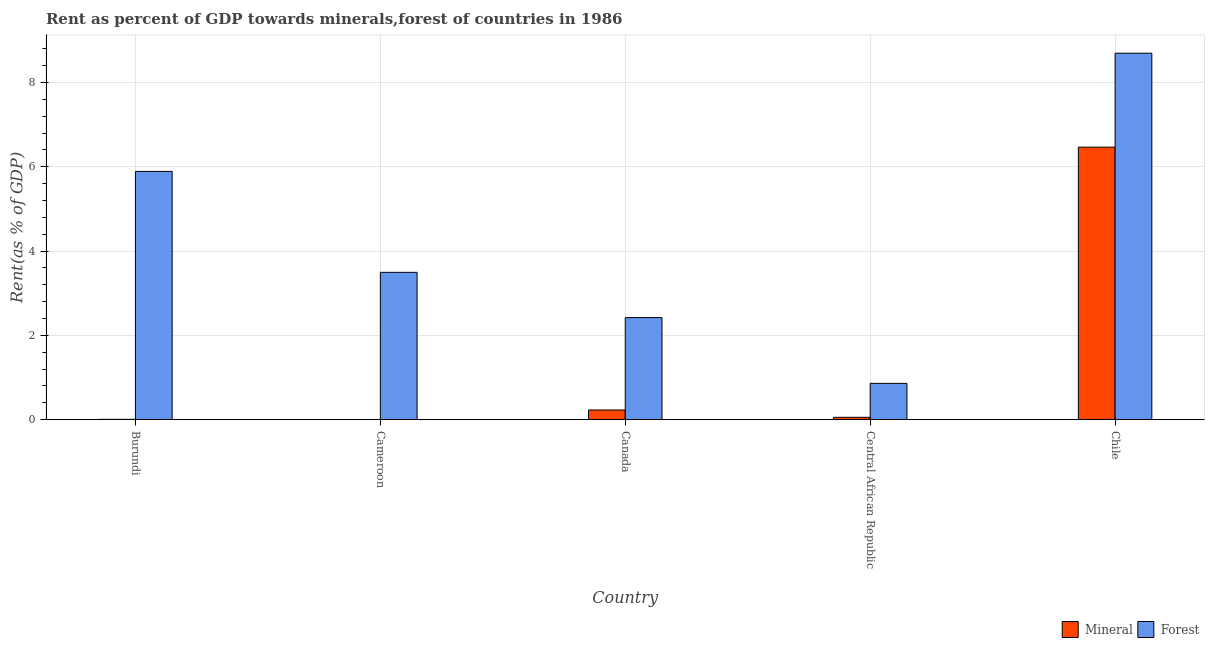What is the label of the 2nd group of bars from the left?
Offer a very short reply. Cameroon. What is the forest rent in Central African Republic?
Ensure brevity in your answer.  0.86. Across all countries, what is the maximum forest rent?
Keep it short and to the point. 8.7. Across all countries, what is the minimum forest rent?
Offer a very short reply. 0.86. In which country was the mineral rent maximum?
Provide a short and direct response. Chile. In which country was the mineral rent minimum?
Make the answer very short. Cameroon. What is the total forest rent in the graph?
Offer a terse response. 21.37. What is the difference between the forest rent in Burundi and that in Canada?
Keep it short and to the point. 3.47. What is the difference between the mineral rent in Chile and the forest rent in Central African Republic?
Your response must be concise. 5.6. What is the average mineral rent per country?
Provide a succinct answer. 1.35. What is the difference between the forest rent and mineral rent in Central African Republic?
Ensure brevity in your answer.  0.81. What is the ratio of the mineral rent in Burundi to that in Chile?
Your answer should be very brief. 0. What is the difference between the highest and the second highest forest rent?
Ensure brevity in your answer.  2.8. What is the difference between the highest and the lowest forest rent?
Provide a succinct answer. 7.83. In how many countries, is the forest rent greater than the average forest rent taken over all countries?
Keep it short and to the point. 2. Is the sum of the forest rent in Canada and Chile greater than the maximum mineral rent across all countries?
Give a very brief answer. Yes. What does the 2nd bar from the left in Canada represents?
Keep it short and to the point. Forest. What does the 1st bar from the right in Central African Republic represents?
Provide a short and direct response. Forest. Are all the bars in the graph horizontal?
Provide a short and direct response. No. How many countries are there in the graph?
Your response must be concise. 5. Are the values on the major ticks of Y-axis written in scientific E-notation?
Offer a terse response. No. Does the graph contain any zero values?
Make the answer very short. No. Does the graph contain grids?
Offer a terse response. Yes. How many legend labels are there?
Keep it short and to the point. 2. How are the legend labels stacked?
Your answer should be compact. Horizontal. What is the title of the graph?
Your response must be concise. Rent as percent of GDP towards minerals,forest of countries in 1986. What is the label or title of the X-axis?
Keep it short and to the point. Country. What is the label or title of the Y-axis?
Offer a terse response. Rent(as % of GDP). What is the Rent(as % of GDP) in Mineral in Burundi?
Make the answer very short. 0.01. What is the Rent(as % of GDP) in Forest in Burundi?
Keep it short and to the point. 5.89. What is the Rent(as % of GDP) of Mineral in Cameroon?
Your answer should be very brief. 0. What is the Rent(as % of GDP) of Forest in Cameroon?
Ensure brevity in your answer.  3.5. What is the Rent(as % of GDP) in Mineral in Canada?
Your answer should be compact. 0.23. What is the Rent(as % of GDP) in Forest in Canada?
Ensure brevity in your answer.  2.42. What is the Rent(as % of GDP) of Mineral in Central African Republic?
Offer a very short reply. 0.06. What is the Rent(as % of GDP) in Forest in Central African Republic?
Provide a succinct answer. 0.86. What is the Rent(as % of GDP) of Mineral in Chile?
Your response must be concise. 6.47. What is the Rent(as % of GDP) in Forest in Chile?
Your answer should be compact. 8.7. Across all countries, what is the maximum Rent(as % of GDP) of Mineral?
Provide a succinct answer. 6.47. Across all countries, what is the maximum Rent(as % of GDP) of Forest?
Ensure brevity in your answer.  8.7. Across all countries, what is the minimum Rent(as % of GDP) in Mineral?
Keep it short and to the point. 0. Across all countries, what is the minimum Rent(as % of GDP) of Forest?
Offer a terse response. 0.86. What is the total Rent(as % of GDP) in Mineral in the graph?
Offer a terse response. 6.76. What is the total Rent(as % of GDP) in Forest in the graph?
Provide a short and direct response. 21.37. What is the difference between the Rent(as % of GDP) in Mineral in Burundi and that in Cameroon?
Ensure brevity in your answer.  0.01. What is the difference between the Rent(as % of GDP) in Forest in Burundi and that in Cameroon?
Ensure brevity in your answer.  2.39. What is the difference between the Rent(as % of GDP) of Mineral in Burundi and that in Canada?
Give a very brief answer. -0.22. What is the difference between the Rent(as % of GDP) in Forest in Burundi and that in Canada?
Make the answer very short. 3.47. What is the difference between the Rent(as % of GDP) of Mineral in Burundi and that in Central African Republic?
Keep it short and to the point. -0.05. What is the difference between the Rent(as % of GDP) of Forest in Burundi and that in Central African Republic?
Offer a very short reply. 5.03. What is the difference between the Rent(as % of GDP) of Mineral in Burundi and that in Chile?
Give a very brief answer. -6.46. What is the difference between the Rent(as % of GDP) in Forest in Burundi and that in Chile?
Offer a terse response. -2.8. What is the difference between the Rent(as % of GDP) in Mineral in Cameroon and that in Canada?
Provide a short and direct response. -0.23. What is the difference between the Rent(as % of GDP) of Forest in Cameroon and that in Canada?
Your answer should be very brief. 1.07. What is the difference between the Rent(as % of GDP) in Mineral in Cameroon and that in Central African Republic?
Keep it short and to the point. -0.06. What is the difference between the Rent(as % of GDP) of Forest in Cameroon and that in Central African Republic?
Your answer should be very brief. 2.63. What is the difference between the Rent(as % of GDP) of Mineral in Cameroon and that in Chile?
Provide a succinct answer. -6.47. What is the difference between the Rent(as % of GDP) of Forest in Cameroon and that in Chile?
Offer a terse response. -5.2. What is the difference between the Rent(as % of GDP) in Mineral in Canada and that in Central African Republic?
Your answer should be very brief. 0.17. What is the difference between the Rent(as % of GDP) in Forest in Canada and that in Central African Republic?
Your response must be concise. 1.56. What is the difference between the Rent(as % of GDP) of Mineral in Canada and that in Chile?
Your response must be concise. -6.24. What is the difference between the Rent(as % of GDP) in Forest in Canada and that in Chile?
Provide a succinct answer. -6.27. What is the difference between the Rent(as % of GDP) in Mineral in Central African Republic and that in Chile?
Offer a very short reply. -6.41. What is the difference between the Rent(as % of GDP) of Forest in Central African Republic and that in Chile?
Give a very brief answer. -7.83. What is the difference between the Rent(as % of GDP) of Mineral in Burundi and the Rent(as % of GDP) of Forest in Cameroon?
Ensure brevity in your answer.  -3.49. What is the difference between the Rent(as % of GDP) of Mineral in Burundi and the Rent(as % of GDP) of Forest in Canada?
Keep it short and to the point. -2.41. What is the difference between the Rent(as % of GDP) in Mineral in Burundi and the Rent(as % of GDP) in Forest in Central African Republic?
Make the answer very short. -0.85. What is the difference between the Rent(as % of GDP) of Mineral in Burundi and the Rent(as % of GDP) of Forest in Chile?
Offer a very short reply. -8.69. What is the difference between the Rent(as % of GDP) of Mineral in Cameroon and the Rent(as % of GDP) of Forest in Canada?
Offer a terse response. -2.42. What is the difference between the Rent(as % of GDP) in Mineral in Cameroon and the Rent(as % of GDP) in Forest in Central African Republic?
Provide a short and direct response. -0.86. What is the difference between the Rent(as % of GDP) of Mineral in Cameroon and the Rent(as % of GDP) of Forest in Chile?
Provide a succinct answer. -8.69. What is the difference between the Rent(as % of GDP) of Mineral in Canada and the Rent(as % of GDP) of Forest in Central African Republic?
Offer a terse response. -0.63. What is the difference between the Rent(as % of GDP) in Mineral in Canada and the Rent(as % of GDP) in Forest in Chile?
Your answer should be very brief. -8.46. What is the difference between the Rent(as % of GDP) in Mineral in Central African Republic and the Rent(as % of GDP) in Forest in Chile?
Your answer should be very brief. -8.64. What is the average Rent(as % of GDP) of Mineral per country?
Ensure brevity in your answer.  1.35. What is the average Rent(as % of GDP) in Forest per country?
Provide a succinct answer. 4.27. What is the difference between the Rent(as % of GDP) of Mineral and Rent(as % of GDP) of Forest in Burundi?
Provide a short and direct response. -5.88. What is the difference between the Rent(as % of GDP) in Mineral and Rent(as % of GDP) in Forest in Cameroon?
Offer a terse response. -3.5. What is the difference between the Rent(as % of GDP) of Mineral and Rent(as % of GDP) of Forest in Canada?
Your answer should be compact. -2.19. What is the difference between the Rent(as % of GDP) of Mineral and Rent(as % of GDP) of Forest in Central African Republic?
Offer a very short reply. -0.81. What is the difference between the Rent(as % of GDP) in Mineral and Rent(as % of GDP) in Forest in Chile?
Offer a terse response. -2.23. What is the ratio of the Rent(as % of GDP) in Mineral in Burundi to that in Cameroon?
Ensure brevity in your answer.  33.14. What is the ratio of the Rent(as % of GDP) in Forest in Burundi to that in Cameroon?
Offer a terse response. 1.68. What is the ratio of the Rent(as % of GDP) in Mineral in Burundi to that in Canada?
Offer a very short reply. 0.04. What is the ratio of the Rent(as % of GDP) of Forest in Burundi to that in Canada?
Keep it short and to the point. 2.43. What is the ratio of the Rent(as % of GDP) of Mineral in Burundi to that in Central African Republic?
Provide a short and direct response. 0.15. What is the ratio of the Rent(as % of GDP) of Forest in Burundi to that in Central African Republic?
Offer a very short reply. 6.83. What is the ratio of the Rent(as % of GDP) of Mineral in Burundi to that in Chile?
Make the answer very short. 0. What is the ratio of the Rent(as % of GDP) in Forest in Burundi to that in Chile?
Give a very brief answer. 0.68. What is the ratio of the Rent(as % of GDP) of Mineral in Cameroon to that in Canada?
Your response must be concise. 0. What is the ratio of the Rent(as % of GDP) in Forest in Cameroon to that in Canada?
Your answer should be very brief. 1.44. What is the ratio of the Rent(as % of GDP) of Mineral in Cameroon to that in Central African Republic?
Keep it short and to the point. 0. What is the ratio of the Rent(as % of GDP) of Forest in Cameroon to that in Central African Republic?
Your response must be concise. 4.06. What is the ratio of the Rent(as % of GDP) of Forest in Cameroon to that in Chile?
Provide a short and direct response. 0.4. What is the ratio of the Rent(as % of GDP) of Mineral in Canada to that in Central African Republic?
Give a very brief answer. 4.07. What is the ratio of the Rent(as % of GDP) of Forest in Canada to that in Central African Republic?
Your answer should be compact. 2.81. What is the ratio of the Rent(as % of GDP) of Mineral in Canada to that in Chile?
Your answer should be compact. 0.04. What is the ratio of the Rent(as % of GDP) in Forest in Canada to that in Chile?
Provide a succinct answer. 0.28. What is the ratio of the Rent(as % of GDP) of Mineral in Central African Republic to that in Chile?
Provide a short and direct response. 0.01. What is the ratio of the Rent(as % of GDP) of Forest in Central African Republic to that in Chile?
Your response must be concise. 0.1. What is the difference between the highest and the second highest Rent(as % of GDP) of Mineral?
Give a very brief answer. 6.24. What is the difference between the highest and the second highest Rent(as % of GDP) of Forest?
Offer a very short reply. 2.8. What is the difference between the highest and the lowest Rent(as % of GDP) in Mineral?
Your response must be concise. 6.47. What is the difference between the highest and the lowest Rent(as % of GDP) in Forest?
Provide a short and direct response. 7.83. 